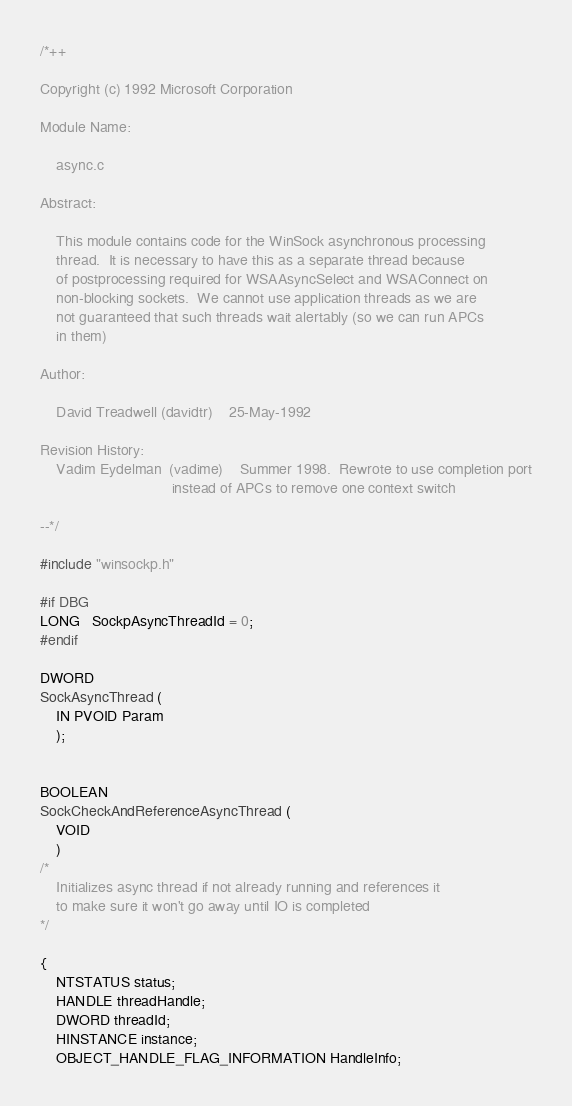<code> <loc_0><loc_0><loc_500><loc_500><_C_>/*++

Copyright (c) 1992 Microsoft Corporation

Module Name:

    async.c

Abstract:

    This module contains code for the WinSock asynchronous processing
    thread.  It is necessary to have this as a separate thread because
    of postprocessing required for WSAAsyncSelect and WSAConnect on
    non-blocking sockets.  We cannot use application threads as we are
    not guaranteed that such threads wait alertably (so we can run APCs
    in them)

Author:

    David Treadwell (davidtr)    25-May-1992

Revision History:
    Vadim Eydelman  (vadime)    Summer 1998.  Rewrote to use completion port
                                instead of APCs to remove one context switch

--*/

#include "winsockp.h"

#if DBG
LONG   SockpAsyncThreadId = 0;
#endif

DWORD
SockAsyncThread (
    IN PVOID Param
    );


BOOLEAN
SockCheckAndReferenceAsyncThread (
    VOID
    )
/*
    Initializes async thread if not already running and references it
    to make sure it won't go away until IO is completed
*/

{
    NTSTATUS status;
    HANDLE threadHandle;
    DWORD threadId;
    HINSTANCE instance;
    OBJECT_HANDLE_FLAG_INFORMATION HandleInfo;</code> 